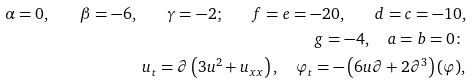<formula> <loc_0><loc_0><loc_500><loc_500>\alpha = 0 , \quad \beta = - 6 , \quad \gamma = - 2 ; \quad f = e = - 2 0 , \quad d = c = - 1 0 , \\ g = - 4 , \quad a = b = 0 \colon \\ u _ { t } = \partial \left ( 3 u ^ { 2 } + u _ { x x } \right ) , \quad \varphi _ { t } = - \left ( 6 u \partial + 2 \partial ^ { 3 } \right ) ( \varphi ) ,</formula> 